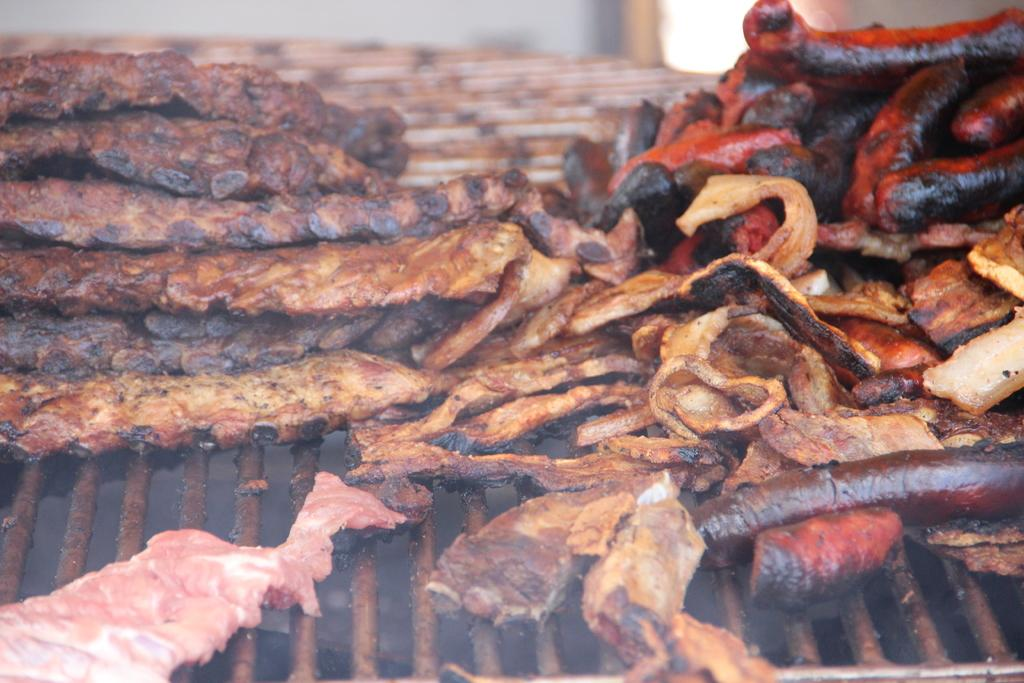What type of cooking appliance is visible in the image? There is a metal grill in the image. What is being cooked on the grill? There are food items on the grill. What can be observed about the color of the food items? The food items are brown and black in color. Can you describe the background of the image? The background of the image is blurry. Are there any feet visible in the image? No, there are no feet visible in the image. What type of toy can be seen on the grill? There are no toys present in the image; it features food items on a metal grill. 